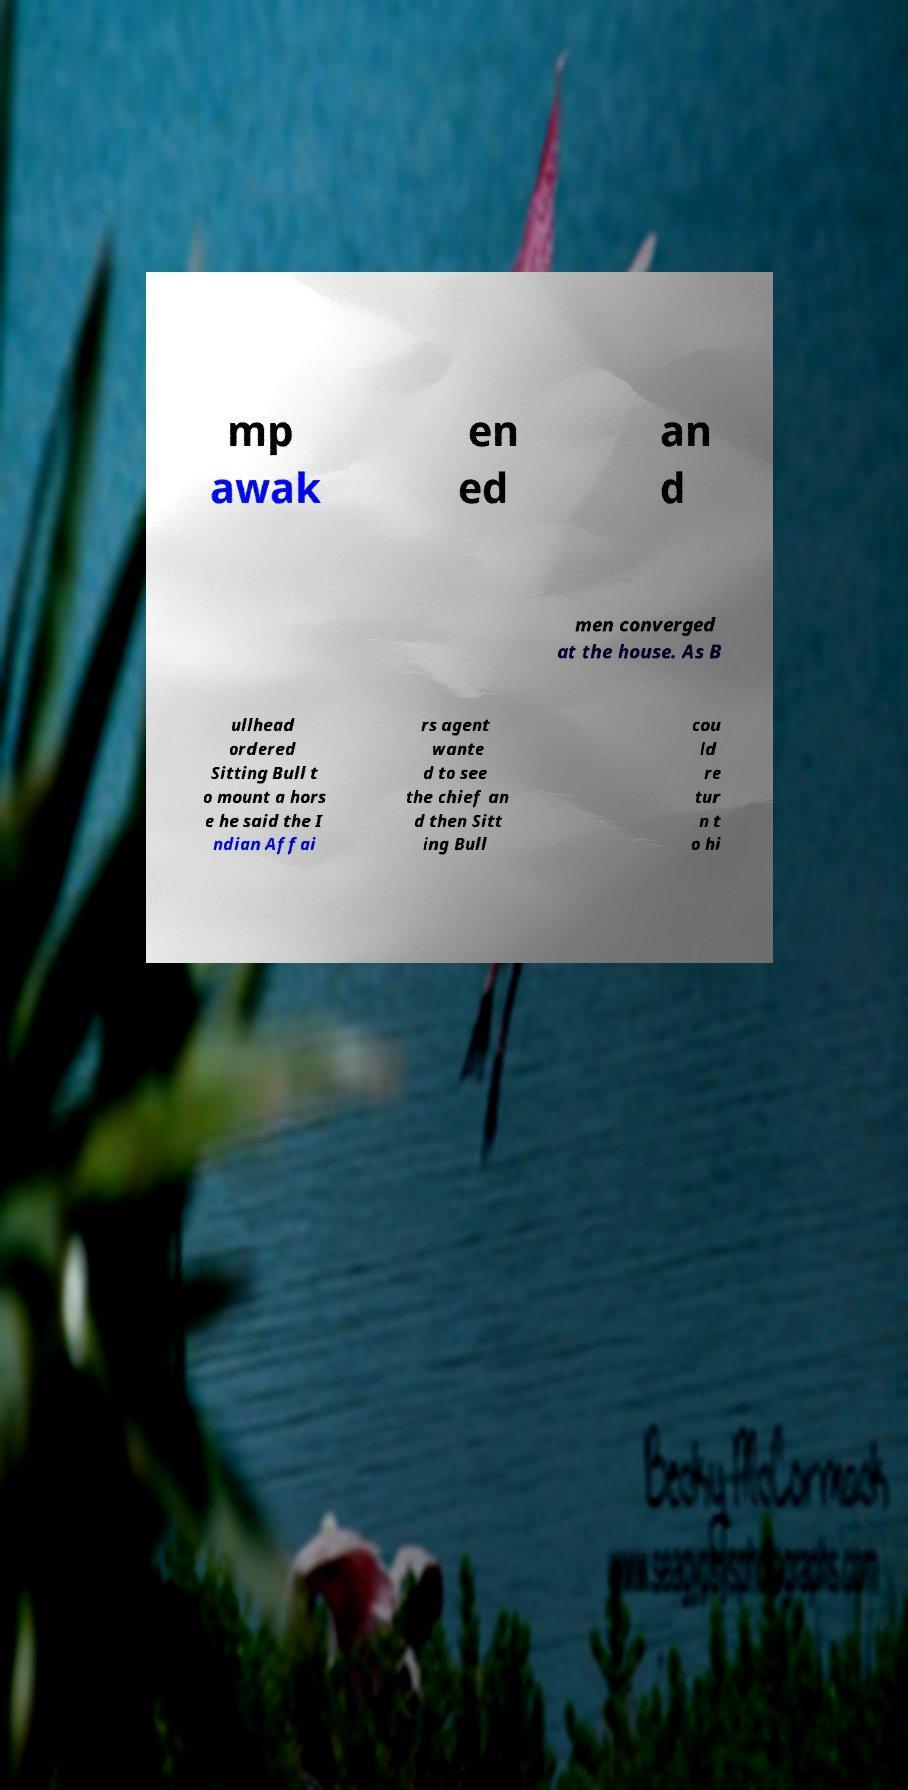For documentation purposes, I need the text within this image transcribed. Could you provide that? mp awak en ed an d men converged at the house. As B ullhead ordered Sitting Bull t o mount a hors e he said the I ndian Affai rs agent wante d to see the chief an d then Sitt ing Bull cou ld re tur n t o hi 